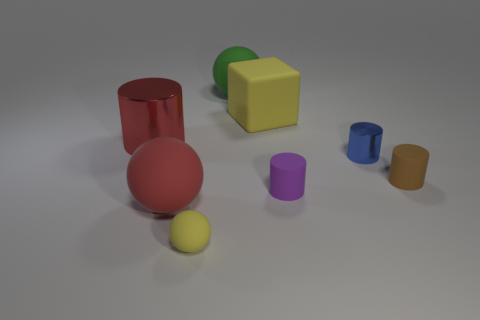Subtract all big matte balls. How many balls are left? 1 Add 1 blue matte balls. How many objects exist? 9 Subtract all blocks. How many objects are left? 7 Subtract all red cylinders. How many cylinders are left? 3 Subtract 1 cubes. How many cubes are left? 0 Add 8 small purple cylinders. How many small purple cylinders are left? 9 Add 2 tiny purple blocks. How many tiny purple blocks exist? 2 Subtract 0 blue cubes. How many objects are left? 8 Subtract all green cubes. Subtract all yellow cylinders. How many cubes are left? 1 Subtract all big green cylinders. Subtract all big yellow objects. How many objects are left? 7 